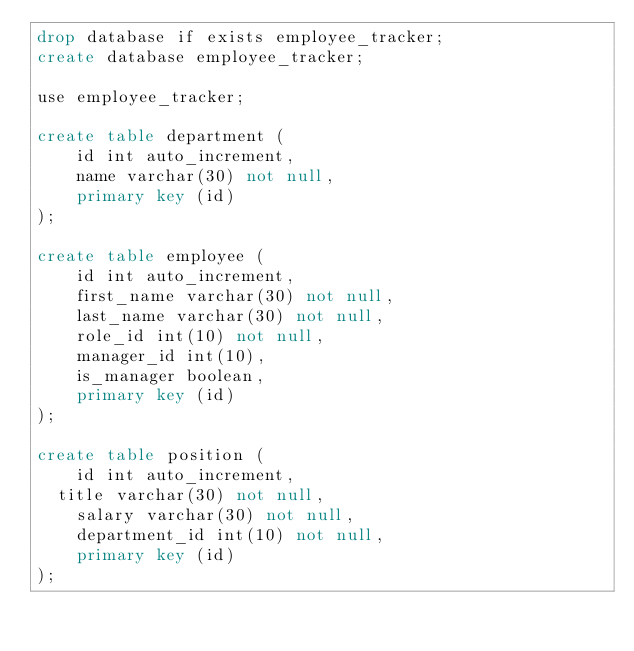Convert code to text. <code><loc_0><loc_0><loc_500><loc_500><_SQL_>drop database if exists employee_tracker;
create database employee_tracker;

use employee_tracker;

create table department (
    id int auto_increment,
    name varchar(30) not null,
    primary key (id)
);

create table employee (
    id int auto_increment,
    first_name varchar(30) not null,
    last_name varchar(30) not null,
    role_id int(10) not null,
    manager_id int(10),
    is_manager boolean,
    primary key (id)
);

create table position (
    id int auto_increment,
	title varchar(30) not null,
    salary varchar(30) not null,
    department_id int(10) not null,
    primary key (id)
);

</code> 